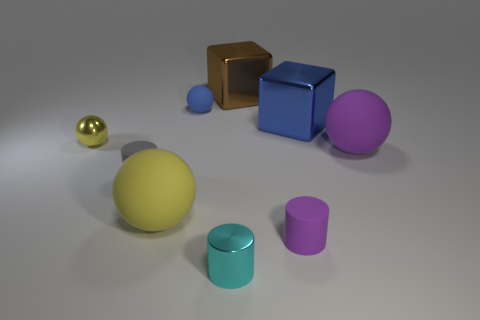Subtract all red spheres. Subtract all yellow cylinders. How many spheres are left? 4 Add 1 small purple cylinders. How many objects exist? 10 Subtract all balls. How many objects are left? 5 Subtract all large purple matte objects. Subtract all large green blocks. How many objects are left? 8 Add 1 small gray rubber cylinders. How many small gray rubber cylinders are left? 2 Add 7 yellow metal balls. How many yellow metal balls exist? 8 Subtract 0 red cubes. How many objects are left? 9 